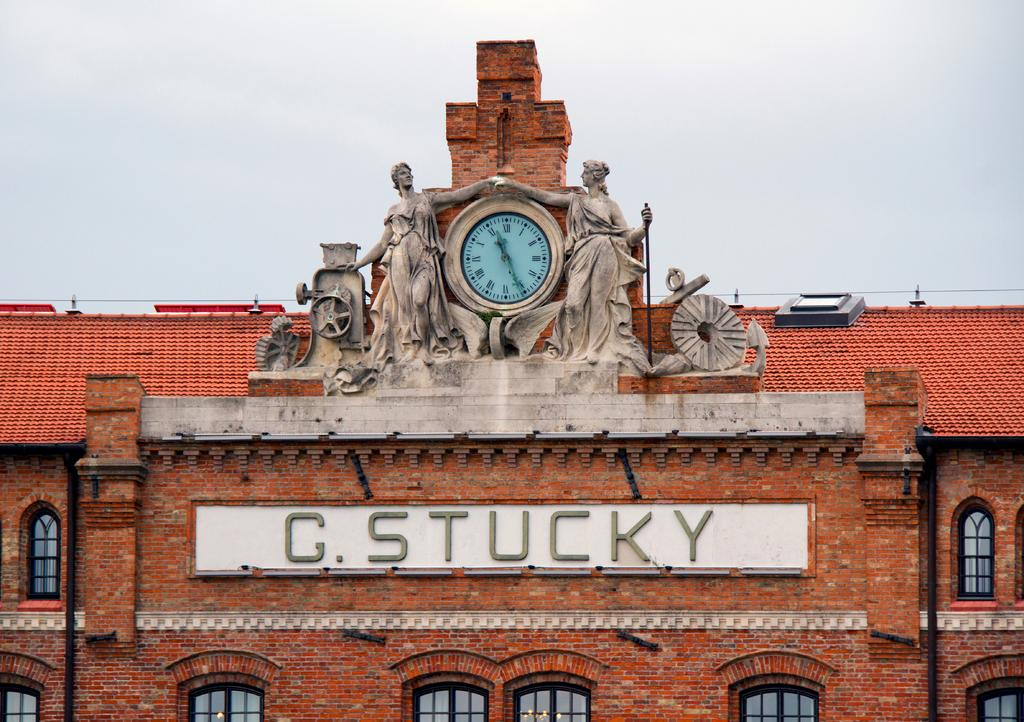What can be found in the center of the image? There are two statues in the center of the image. What time-telling device is present in the image? There is a wall clock in the image. Where is the wall clock located? The wall clock is on a building. What architectural feature is present on the building? The building contains a group of windows. Is there any text visible on the building? Yes, there is some text on the building. What can be seen in the background of the image? The sky is visible in the background of the image. What type of silk is being used to create the slope in the image? There is no silk or slope present in the image. How is the yarn being used to decorate the statues in the image? There is no yarn or decoration of statues present in the image. 